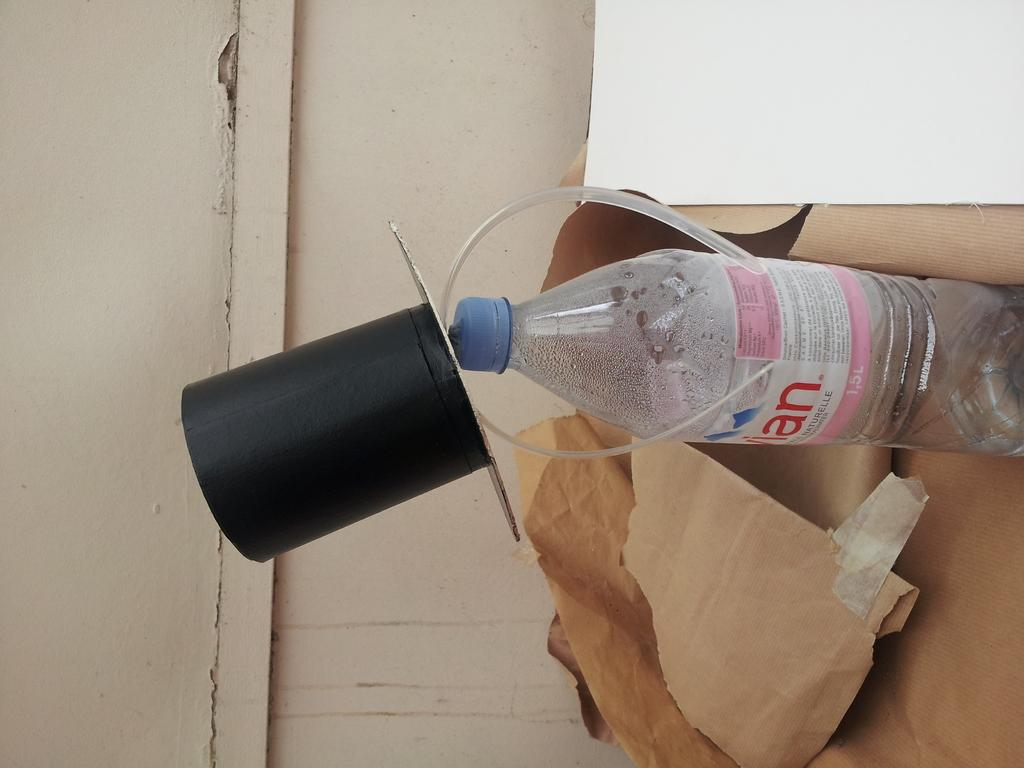<image>
Write a terse but informative summary of the picture. An Evian water bottle with a hate is sticking out of a paper bag. 